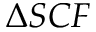Convert formula to latex. <formula><loc_0><loc_0><loc_500><loc_500>\Delta S C F</formula> 